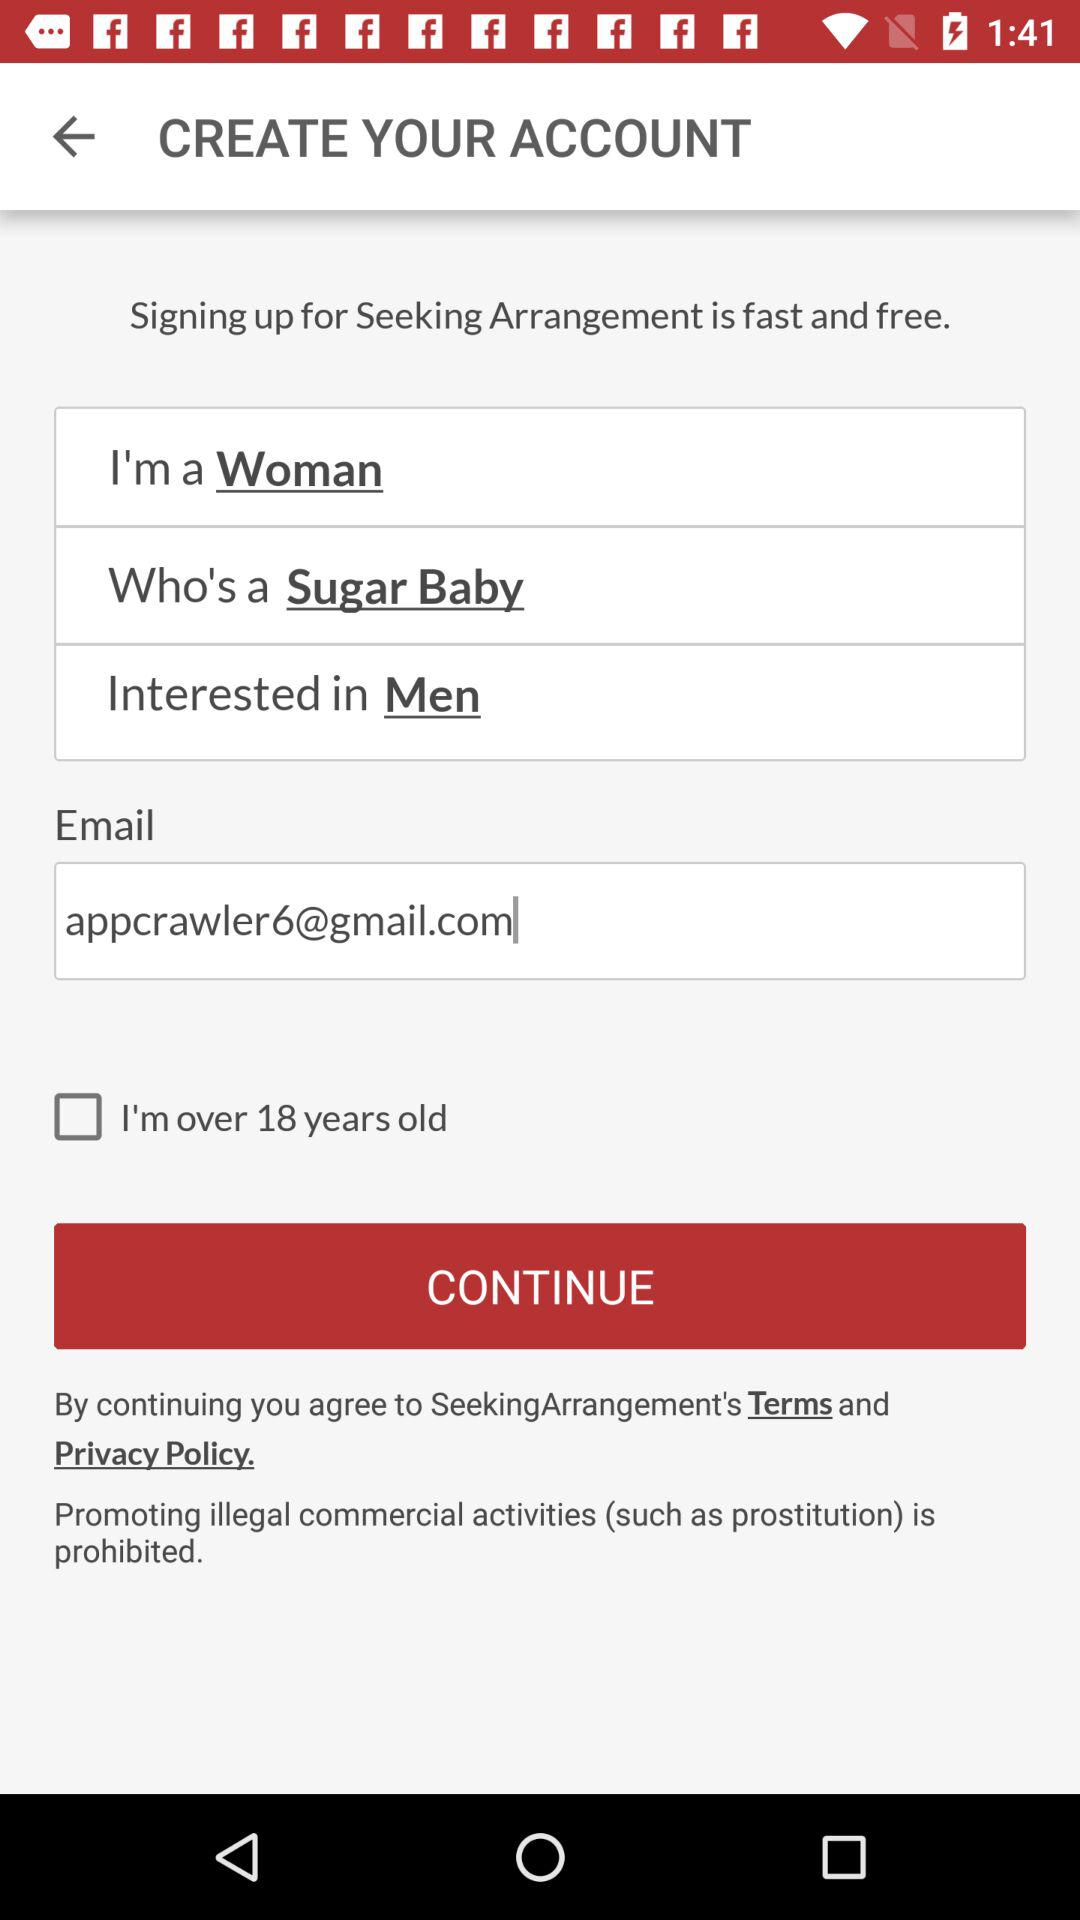What is the status of "I'm over 18 years old"? The status is "off". 